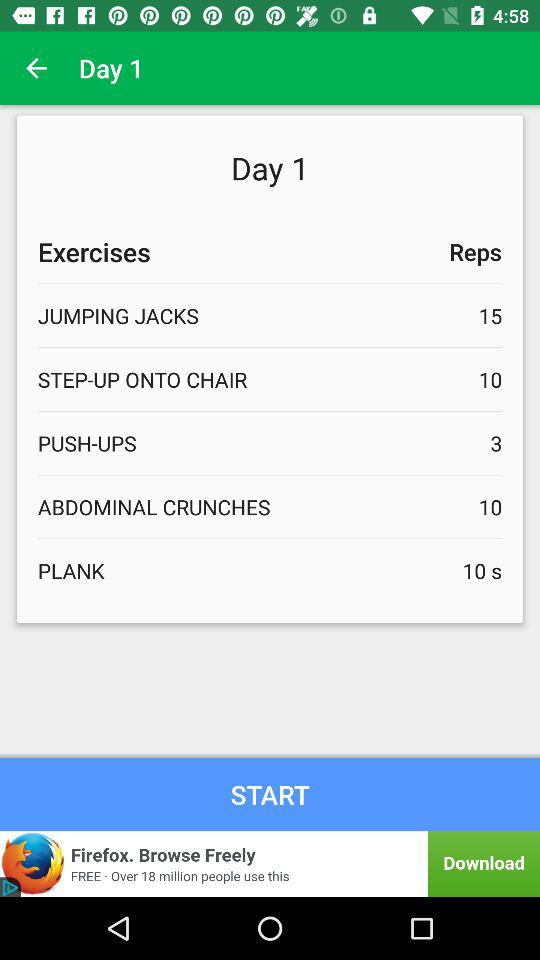How many seconds of plank on day 1? There are 10 seconds of plank on day 1. 